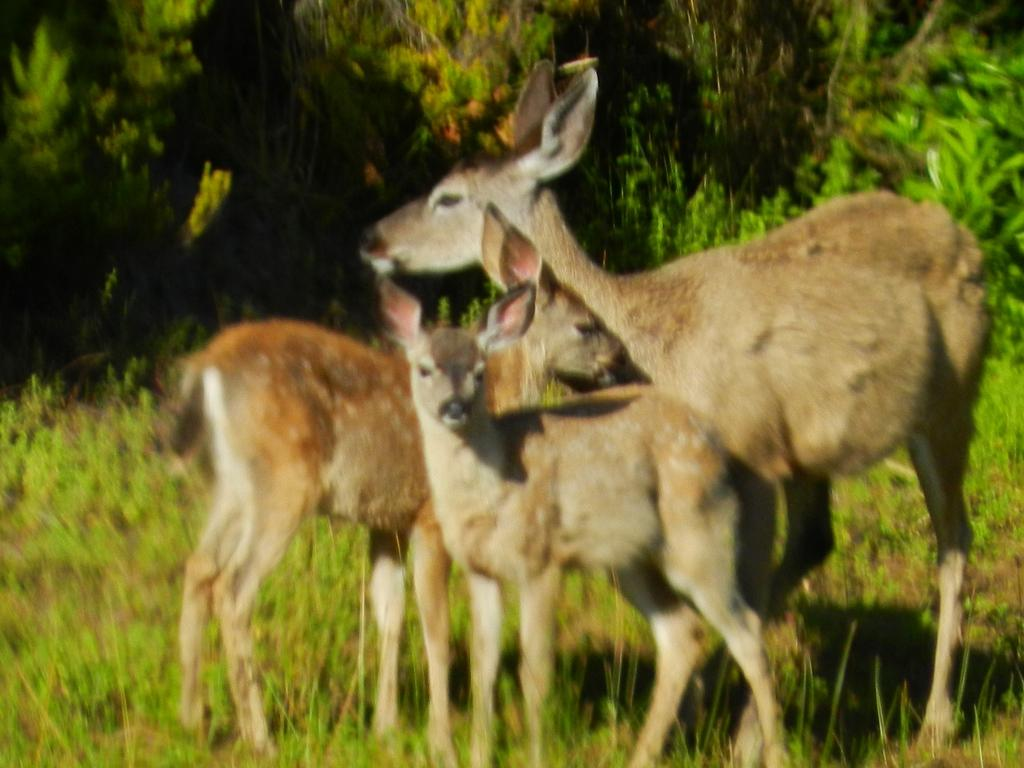How many deer are present in the image? There are three deer in the image. What is the position of the deer in the image? The deer are standing on the ground. What type of vegetation is present on the ground? There is grass on the ground. What can be seen in the background of the image? There are plants visible in the background of the image. What type of cake is being served to the deer in the image? There is no cake present in the image; it features three deer standing on the ground with grass and plants visible in the background. 